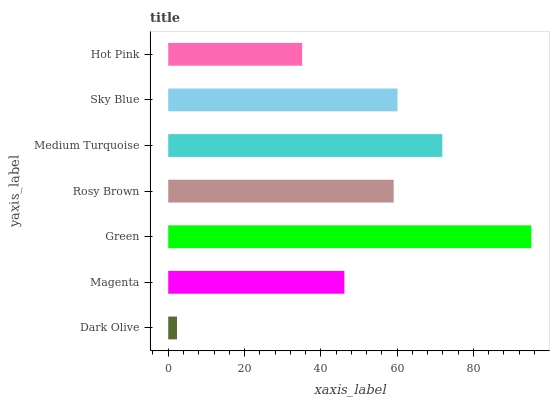Is Dark Olive the minimum?
Answer yes or no. Yes. Is Green the maximum?
Answer yes or no. Yes. Is Magenta the minimum?
Answer yes or no. No. Is Magenta the maximum?
Answer yes or no. No. Is Magenta greater than Dark Olive?
Answer yes or no. Yes. Is Dark Olive less than Magenta?
Answer yes or no. Yes. Is Dark Olive greater than Magenta?
Answer yes or no. No. Is Magenta less than Dark Olive?
Answer yes or no. No. Is Rosy Brown the high median?
Answer yes or no. Yes. Is Rosy Brown the low median?
Answer yes or no. Yes. Is Green the high median?
Answer yes or no. No. Is Magenta the low median?
Answer yes or no. No. 